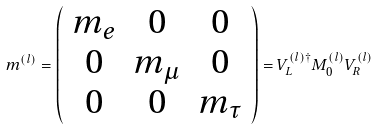Convert formula to latex. <formula><loc_0><loc_0><loc_500><loc_500>m ^ { ( l ) } = \left ( \begin{array} { * { 3 } { c } } m _ { e } & 0 & 0 \\ 0 & m _ { \mu } & 0 \\ 0 & 0 & m _ { \tau } \\ \end{array} \right ) = V _ { L } ^ { ( l ) \dagger } M _ { 0 } ^ { ( l ) } V _ { R } ^ { ( l ) }</formula> 